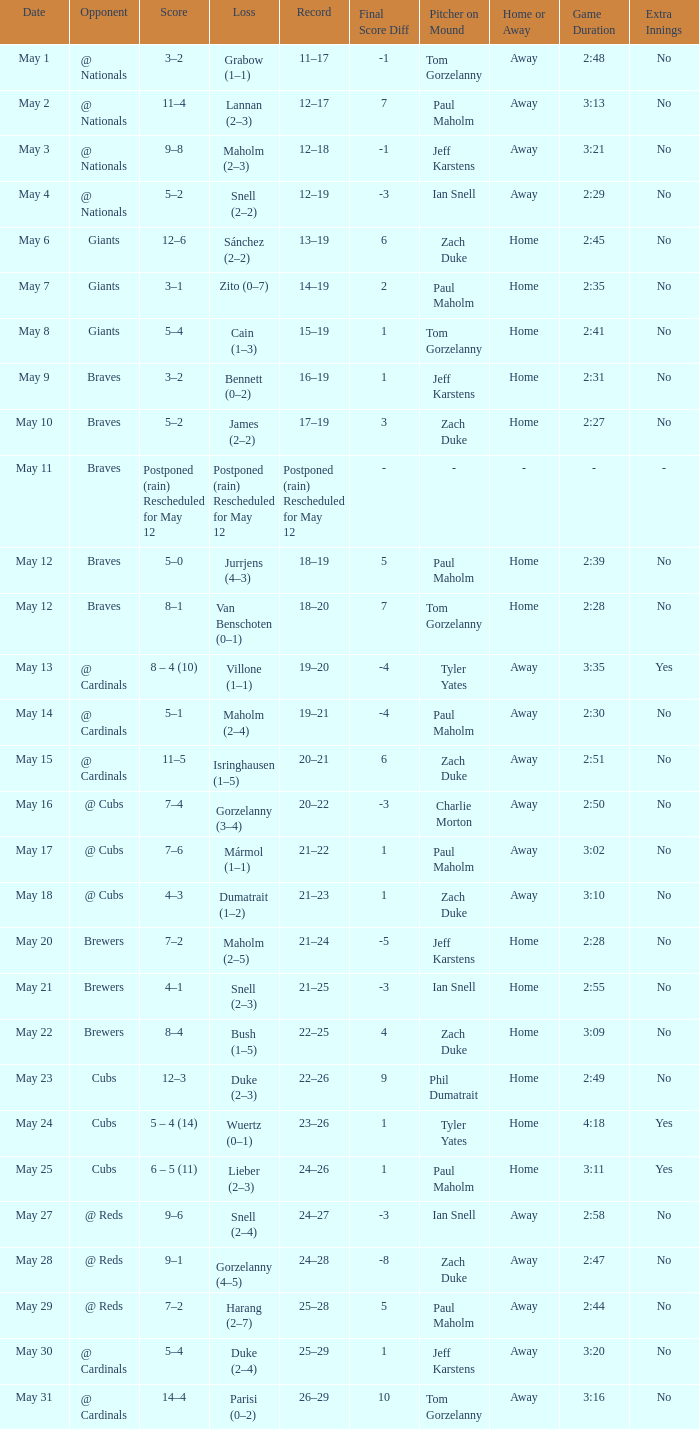What was the record of the game with a score of 12–6? 13–19. 